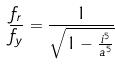<formula> <loc_0><loc_0><loc_500><loc_500>\frac { f _ { r } } { f _ { y } } = \frac { 1 } { \sqrt { 1 - \frac { i ^ { 5 } } { a ^ { 5 } } } }</formula> 